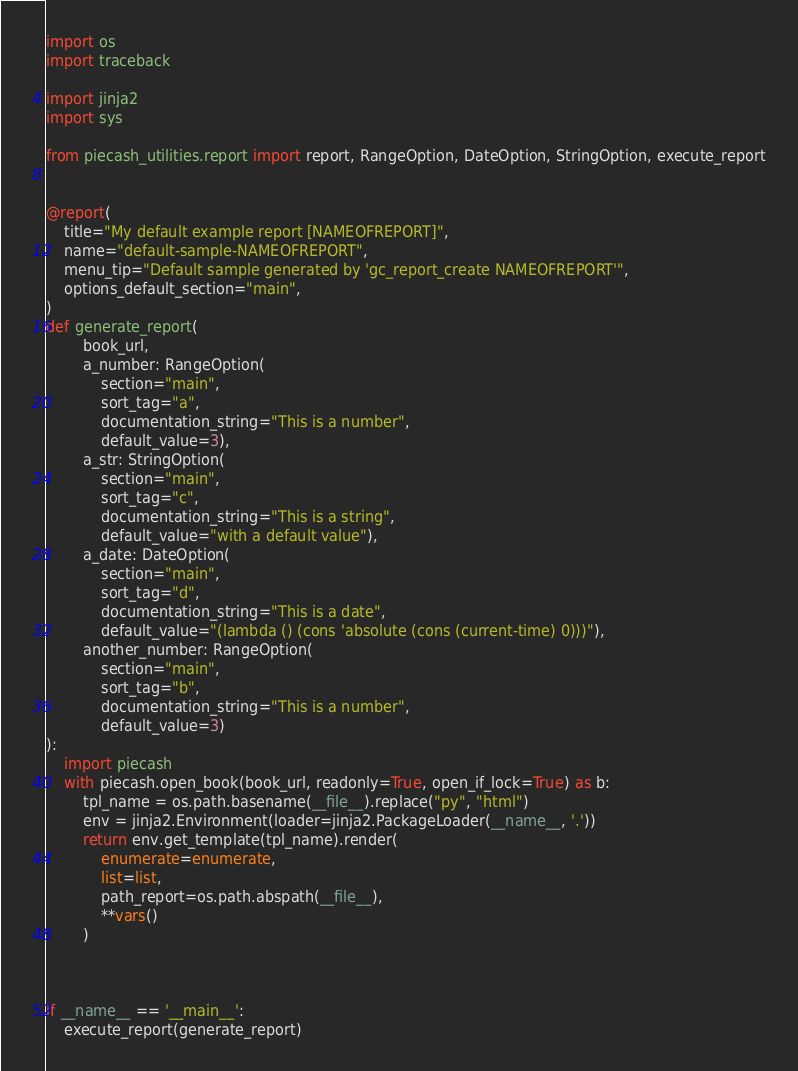Convert code to text. <code><loc_0><loc_0><loc_500><loc_500><_Python_>import os
import traceback

import jinja2
import sys

from piecash_utilities.report import report, RangeOption, DateOption, StringOption, execute_report


@report(
    title="My default example report [NAMEOFREPORT]",
    name="default-sample-NAMEOFREPORT",
    menu_tip="Default sample generated by 'gc_report_create NAMEOFREPORT'",
    options_default_section="main",
)
def generate_report(
        book_url,
        a_number: RangeOption(
            section="main",
            sort_tag="a",
            documentation_string="This is a number",
            default_value=3),
        a_str: StringOption(
            section="main",
            sort_tag="c",
            documentation_string="This is a string",
            default_value="with a default value"),
        a_date: DateOption(
            section="main",
            sort_tag="d",
            documentation_string="This is a date",
            default_value="(lambda () (cons 'absolute (cons (current-time) 0)))"),
        another_number: RangeOption(
            section="main",
            sort_tag="b",
            documentation_string="This is a number",
            default_value=3)
):
    import piecash
    with piecash.open_book(book_url, readonly=True, open_if_lock=True) as b:
        tpl_name = os.path.basename(__file__).replace("py", "html")
        env = jinja2.Environment(loader=jinja2.PackageLoader(__name__, '.'))
        return env.get_template(tpl_name).render(
            enumerate=enumerate,
            list=list,
            path_report=os.path.abspath(__file__),
            **vars()
        )



if __name__ == '__main__':
    execute_report(generate_report)
</code> 